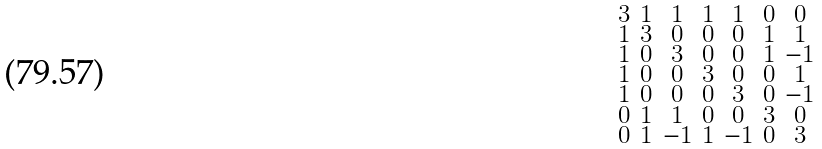<formula> <loc_0><loc_0><loc_500><loc_500>\begin{smallmatrix} 3 & 1 & 1 & 1 & 1 & 0 & 0 \\ 1 & 3 & 0 & 0 & 0 & 1 & 1 \\ 1 & 0 & 3 & 0 & 0 & 1 & - 1 \\ 1 & 0 & 0 & 3 & 0 & 0 & 1 \\ 1 & 0 & 0 & 0 & 3 & 0 & - 1 \\ 0 & 1 & 1 & 0 & 0 & 3 & 0 \\ 0 & 1 & - 1 & 1 & - 1 & 0 & 3 \end{smallmatrix}</formula> 